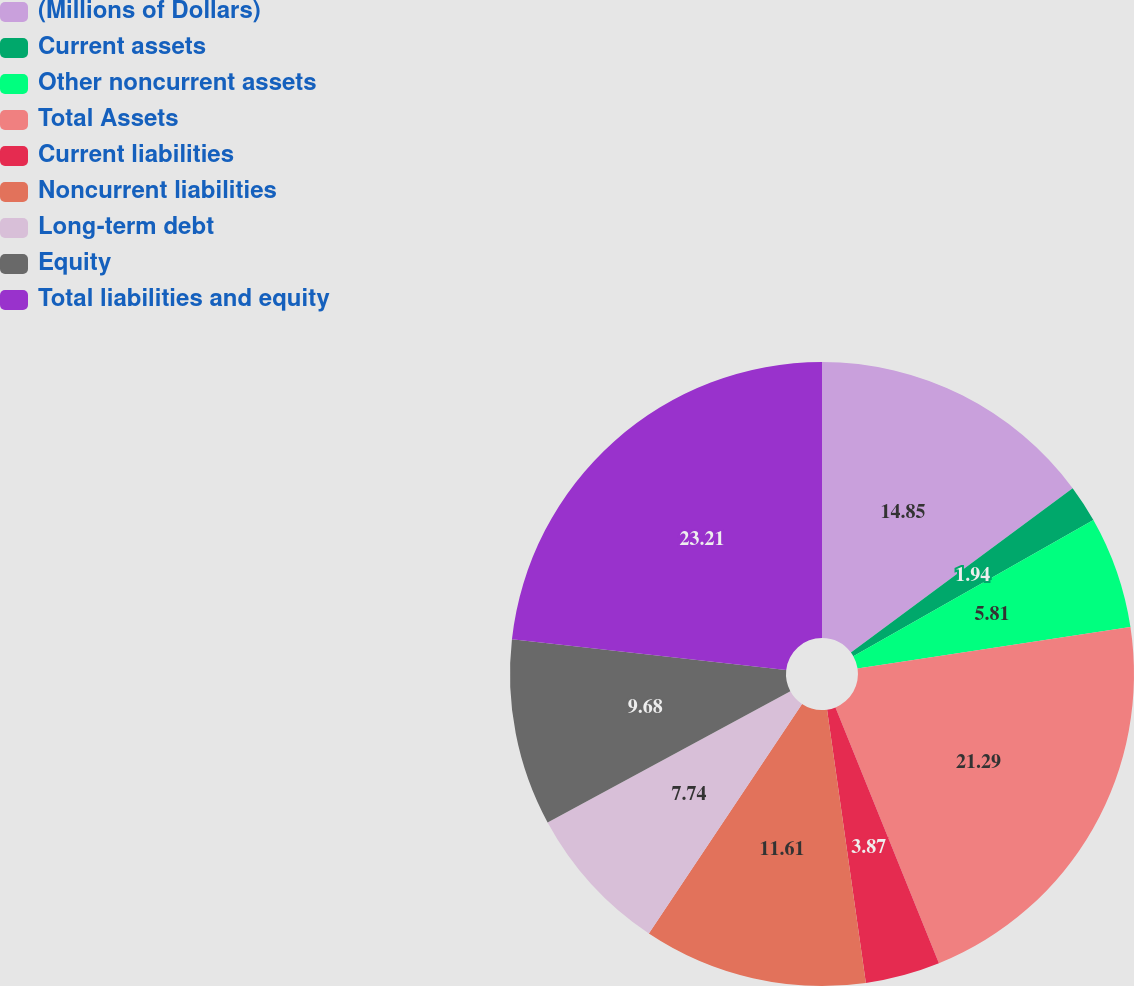Convert chart. <chart><loc_0><loc_0><loc_500><loc_500><pie_chart><fcel>(Millions of Dollars)<fcel>Current assets<fcel>Other noncurrent assets<fcel>Total Assets<fcel>Current liabilities<fcel>Noncurrent liabilities<fcel>Long-term debt<fcel>Equity<fcel>Total liabilities and equity<nl><fcel>14.85%<fcel>1.94%<fcel>5.81%<fcel>21.29%<fcel>3.87%<fcel>11.61%<fcel>7.74%<fcel>9.68%<fcel>23.22%<nl></chart> 